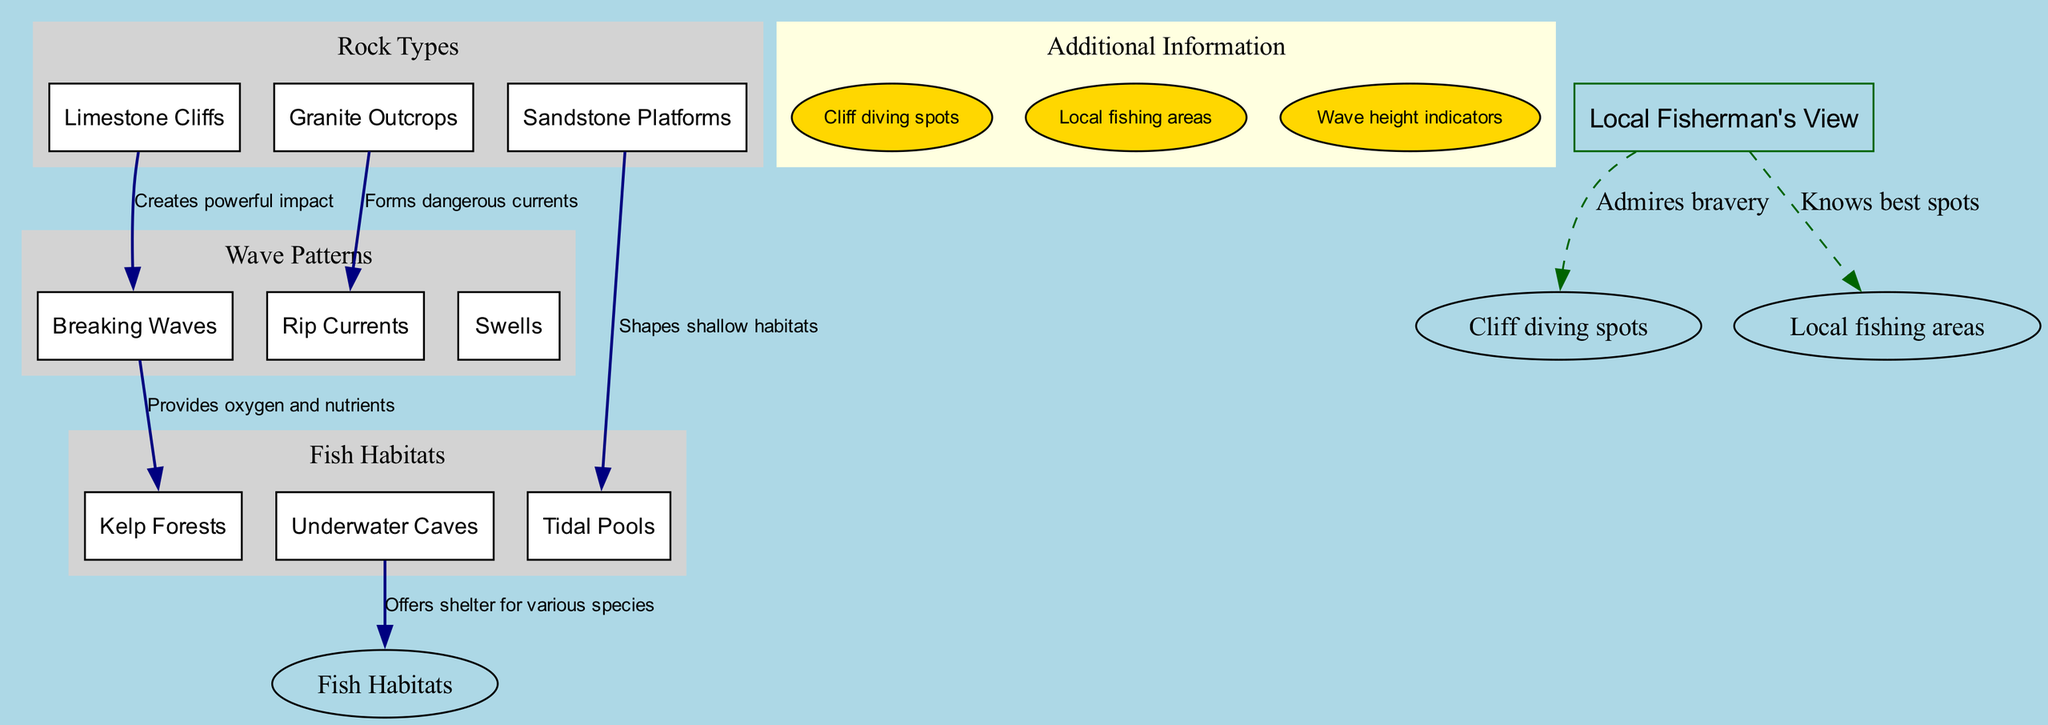What are the three rock types mentioned? The diagram lists three rock types in the "Rock Types" section: Limestone Cliffs, Granite Outcrops, and Sandstone Platforms. These can be found grouped together in the respective section.
Answer: Limestone Cliffs, Granite Outcrops, Sandstone Platforms How many types of wave patterns are included? The "Wave Patterns" section of the diagram contains three elements: Breaking Waves, Rip Currents, and Swells. By counting the list items in this section, we find that there are three types.
Answer: 3 What impact do Limestone Cliffs have on wave patterns? The connection from Limestone Cliffs to Breaking Waves is labeled "Creates powerful impact," indicating that these cliffs significantly affect the wave dynamics by creating strong forces when waves break against them.
Answer: Creates powerful impact Which fish habitat is shaped by Sandstone Platforms? According to the diagram, Sandstone Platforms are connected to Tidal Pools, as indicated by the label "Shapes shallow habitats." This shows that the features formed by the sandstone influence the creation of tidal pools for fish and marine life.
Answer: Tidal Pools What provides oxygen and nutrients to Kelp Forests? The diagram connects Breaking Waves to Kelp Forests with the label "Provides oxygen and nutrients." This indicates that the action of the waves helps to support the kelp forest ecosystems by delivering vital resources.
Answer: Breaking Waves How do Granite Outcrops affect wave patterns? The connection shows that Granite Outcrops form Rip Currents, as indicated by the label "Forms dangerous currents." This relationship highlights the hazardous effect these outcrops can have on water movement.
Answer: Forms dangerous currents What type of information is provided in the additional information section? The "Additional Information" section lists "Cliff diving spots," "Local fishing areas," and "Wave height indicators," which offer relevant details that could enhance understanding or practical applications related to the diagram’s content.
Answer: Cliff diving spots, Local fishing areas, Wave height indicators What role do Underwater Caves play in fish habitats? The connection from Underwater Caves to Fish Habitats is labeled "Offers shelter for various species." This indicates that the caves provide a refuge for different kinds of marine life, supporting biodiversity.
Answer: Offers shelter for various species How many total connections are made in the diagram? The diagram lists five connections between rock types, wave patterns, and fish habitats. By reviewing the connections section, you can count each labeled relationship to determine that there are five in total.
Answer: 5 